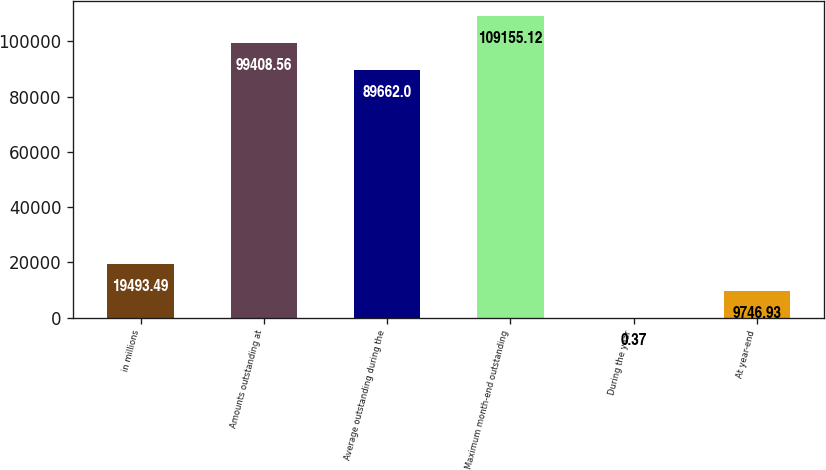Convert chart. <chart><loc_0><loc_0><loc_500><loc_500><bar_chart><fcel>in millions<fcel>Amounts outstanding at<fcel>Average outstanding during the<fcel>Maximum month-end outstanding<fcel>During the year<fcel>At year-end<nl><fcel>19493.5<fcel>99408.6<fcel>89662<fcel>109155<fcel>0.37<fcel>9746.93<nl></chart> 